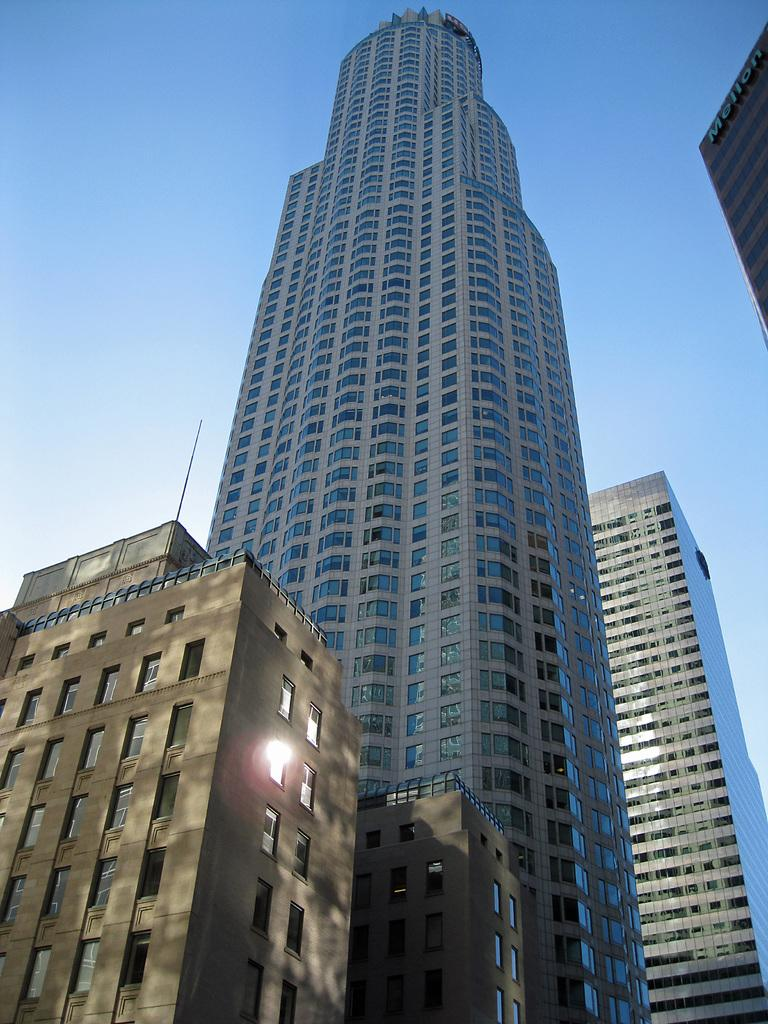What type of structures are located on the left side of the image? There are buildings on the left side of the image. What type of structures are located on the right side of the image? There are buildings on the right side of the image. Can you describe a specific type of building in the image? Yes, there is a skyscraper in the image. What is visible at the top of the image? The sky is visible at the top of the image. How many legs can be seen on the quill in the image? There is no quill present in the image, so it is not possible to determine the number of legs on a quill. 